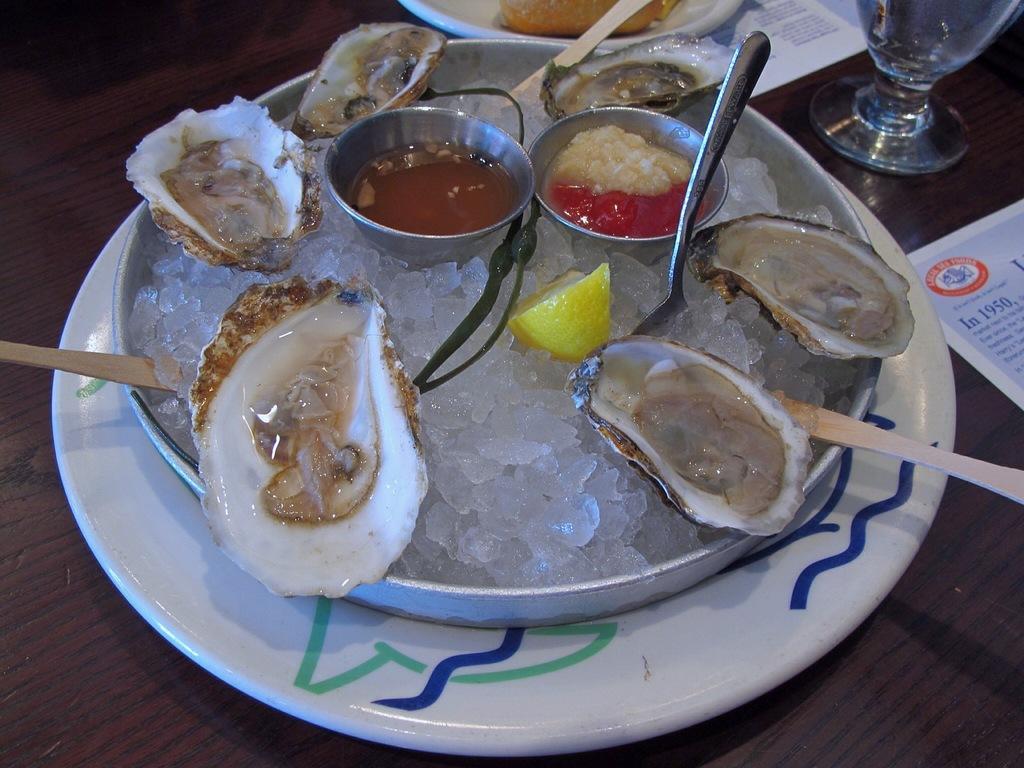How would you summarize this image in a sentence or two? In this picture I can see spoons and some food items on white color plate. Here I can see a glass and some other objects on a wooden table. 